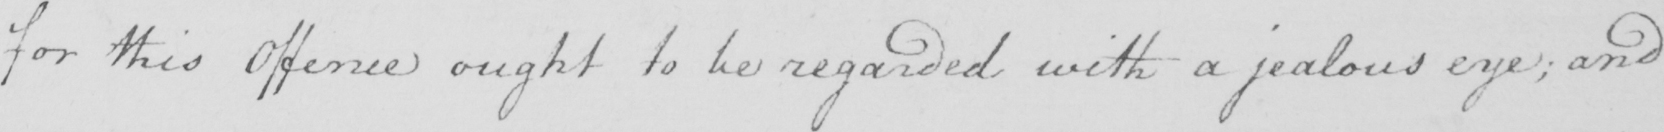Please provide the text content of this handwritten line. for this Offence ought to be regarded with a jealous eye ; and 